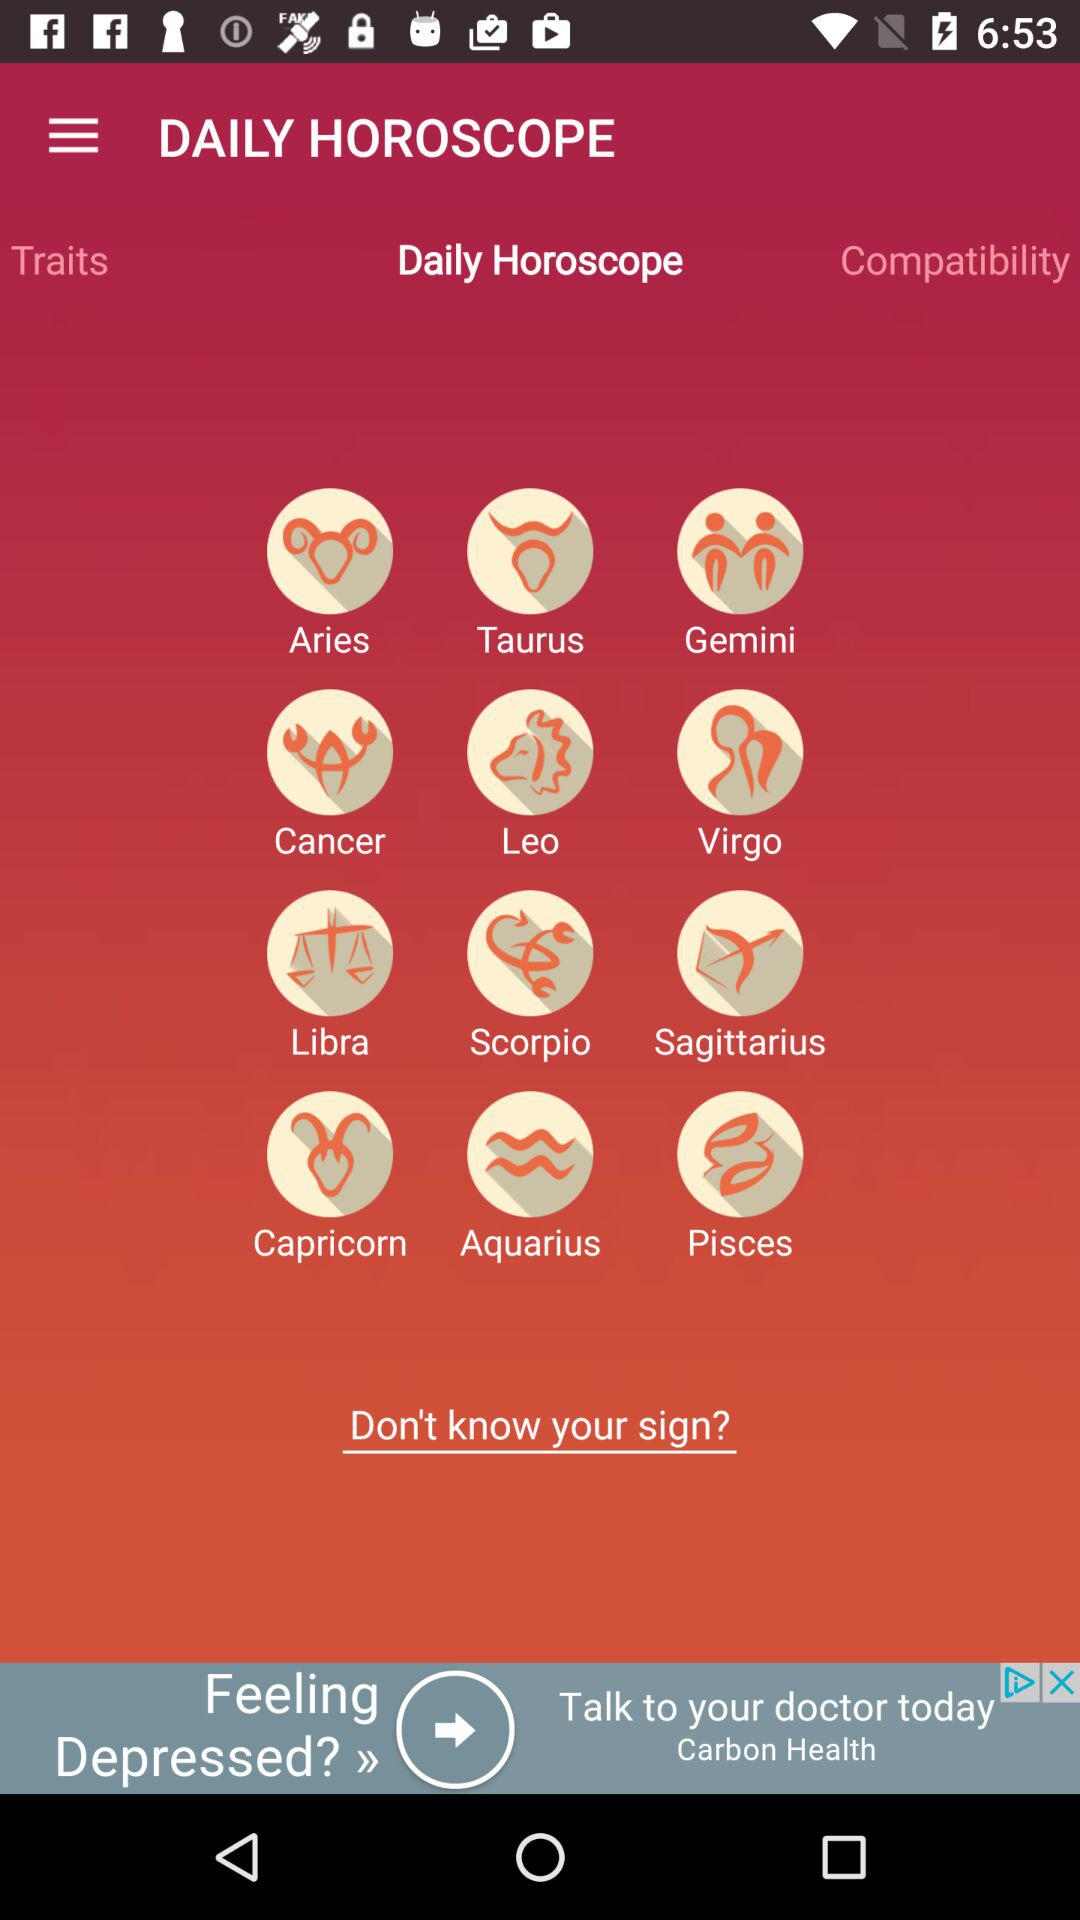How many signs are in the zodiac?
Answer the question using a single word or phrase. 12 